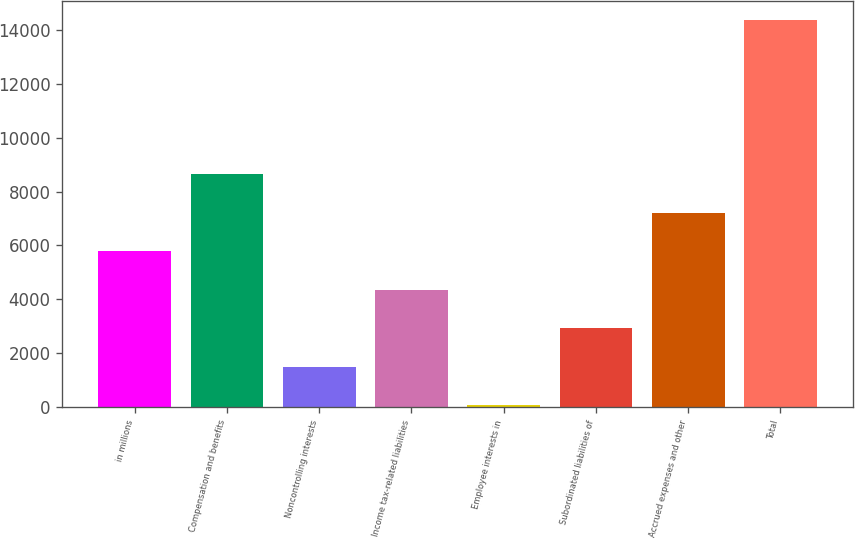Convert chart. <chart><loc_0><loc_0><loc_500><loc_500><bar_chart><fcel>in millions<fcel>Compensation and benefits<fcel>Noncontrolling interests<fcel>Income tax-related liabilities<fcel>Employee interests in<fcel>Subordinated liabilities of<fcel>Accrued expenses and other<fcel>Total<nl><fcel>5791<fcel>8648<fcel>1505.5<fcel>4362.5<fcel>77<fcel>2934<fcel>7219.5<fcel>14362<nl></chart> 